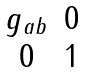<formula> <loc_0><loc_0><loc_500><loc_500>\begin{matrix} g _ { a b } & 0 \\ 0 & 1 \end{matrix}</formula> 